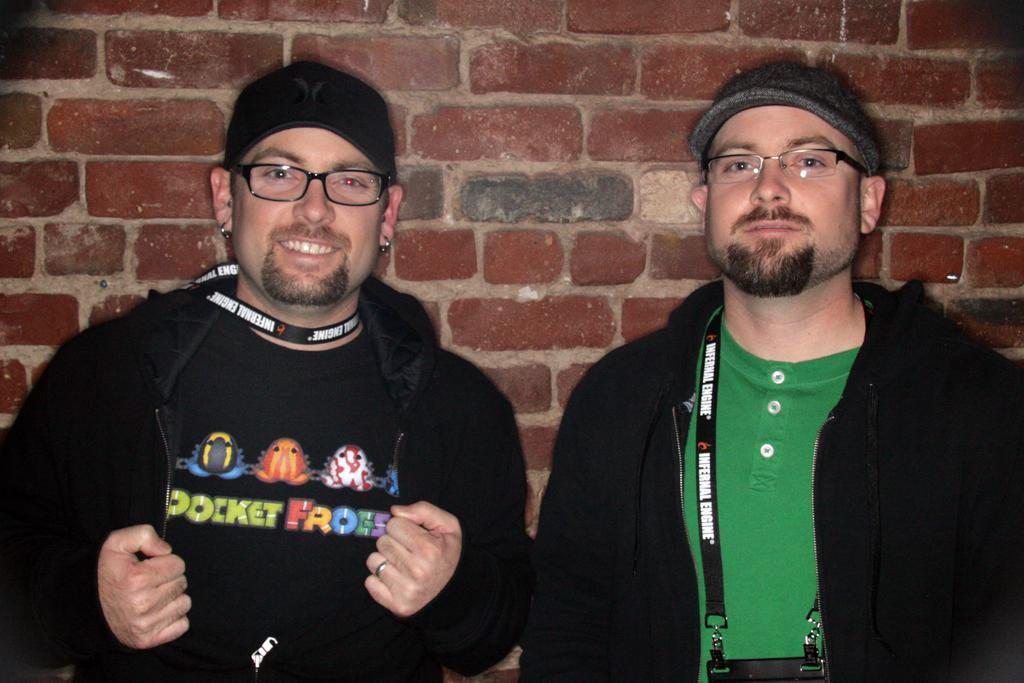How would you summarize this image in a sentence or two? In this image we can see two persons wearing the glasses and one of the person is smiling. In the background we can see the brick wall. 